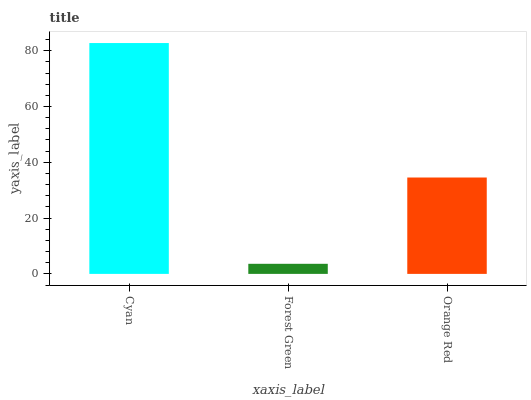Is Forest Green the minimum?
Answer yes or no. Yes. Is Cyan the maximum?
Answer yes or no. Yes. Is Orange Red the minimum?
Answer yes or no. No. Is Orange Red the maximum?
Answer yes or no. No. Is Orange Red greater than Forest Green?
Answer yes or no. Yes. Is Forest Green less than Orange Red?
Answer yes or no. Yes. Is Forest Green greater than Orange Red?
Answer yes or no. No. Is Orange Red less than Forest Green?
Answer yes or no. No. Is Orange Red the high median?
Answer yes or no. Yes. Is Orange Red the low median?
Answer yes or no. Yes. Is Cyan the high median?
Answer yes or no. No. Is Forest Green the low median?
Answer yes or no. No. 